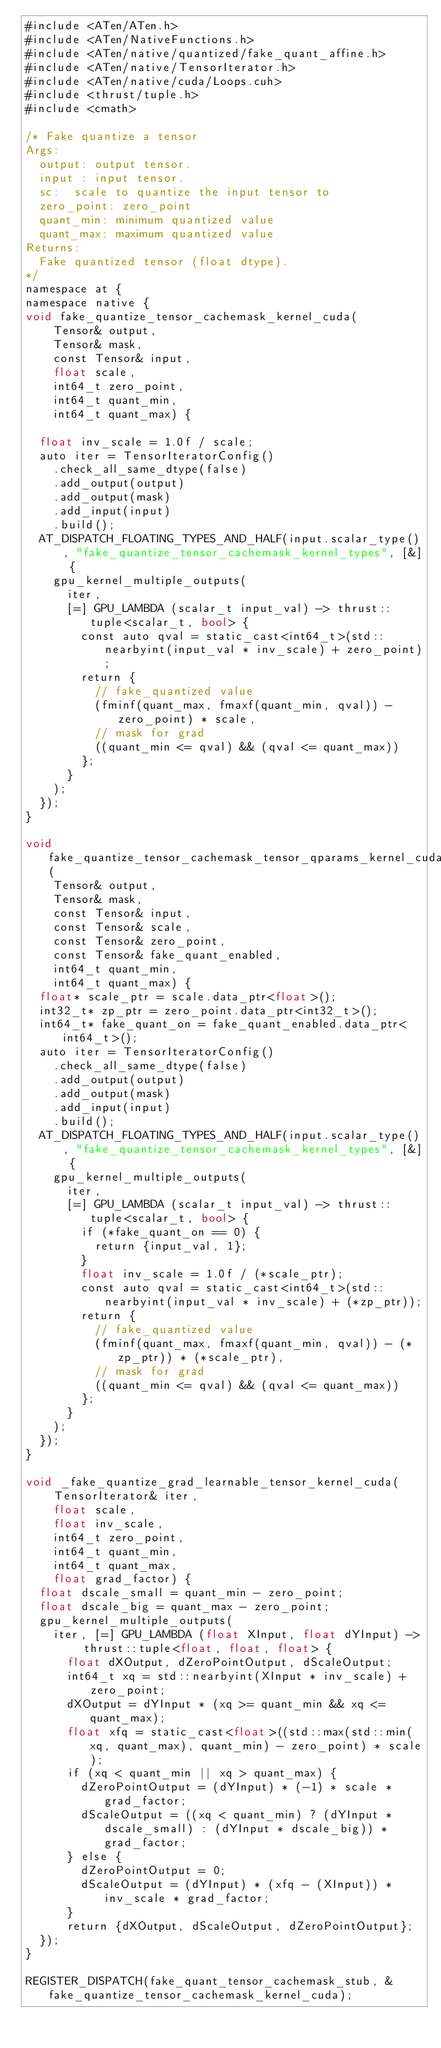<code> <loc_0><loc_0><loc_500><loc_500><_Cuda_>#include <ATen/ATen.h>
#include <ATen/NativeFunctions.h>
#include <ATen/native/quantized/fake_quant_affine.h>
#include <ATen/native/TensorIterator.h>
#include <ATen/native/cuda/Loops.cuh>
#include <thrust/tuple.h>
#include <cmath>

/* Fake quantize a tensor
Args:
  output: output tensor.
  input : input tensor.
  sc:  scale to quantize the input tensor to
  zero_point: zero_point
  quant_min: minimum quantized value
  quant_max: maximum quantized value
Returns:
  Fake quantized tensor (float dtype).
*/
namespace at {
namespace native {
void fake_quantize_tensor_cachemask_kernel_cuda(
    Tensor& output,
    Tensor& mask,
    const Tensor& input,
    float scale,
    int64_t zero_point,
    int64_t quant_min,
    int64_t quant_max) {

  float inv_scale = 1.0f / scale;
  auto iter = TensorIteratorConfig()
    .check_all_same_dtype(false)
    .add_output(output)
    .add_output(mask)
    .add_input(input)
    .build();
  AT_DISPATCH_FLOATING_TYPES_AND_HALF(input.scalar_type(), "fake_quantize_tensor_cachemask_kernel_types", [&] {
    gpu_kernel_multiple_outputs(
      iter,
      [=] GPU_LAMBDA (scalar_t input_val) -> thrust::tuple<scalar_t, bool> {
        const auto qval = static_cast<int64_t>(std::nearbyint(input_val * inv_scale) + zero_point);
        return {
          // fake_quantized value
          (fminf(quant_max, fmaxf(quant_min, qval)) - zero_point) * scale,
          // mask for grad
          ((quant_min <= qval) && (qval <= quant_max))
        };
      }
    );
  });
}

void fake_quantize_tensor_cachemask_tensor_qparams_kernel_cuda(
    Tensor& output,
    Tensor& mask,
    const Tensor& input,
    const Tensor& scale,
    const Tensor& zero_point,
    const Tensor& fake_quant_enabled,
    int64_t quant_min,
    int64_t quant_max) {
  float* scale_ptr = scale.data_ptr<float>();
  int32_t* zp_ptr = zero_point.data_ptr<int32_t>();
  int64_t* fake_quant_on = fake_quant_enabled.data_ptr<int64_t>();
  auto iter = TensorIteratorConfig()
    .check_all_same_dtype(false)
    .add_output(output)
    .add_output(mask)
    .add_input(input)
    .build();
  AT_DISPATCH_FLOATING_TYPES_AND_HALF(input.scalar_type(), "fake_quantize_tensor_cachemask_kernel_types", [&] {
    gpu_kernel_multiple_outputs(
      iter,
      [=] GPU_LAMBDA (scalar_t input_val) -> thrust::tuple<scalar_t, bool> {
        if (*fake_quant_on == 0) {
          return {input_val, 1};
        }
        float inv_scale = 1.0f / (*scale_ptr);
        const auto qval = static_cast<int64_t>(std::nearbyint(input_val * inv_scale) + (*zp_ptr));
        return {
          // fake_quantized value
          (fminf(quant_max, fmaxf(quant_min, qval)) - (*zp_ptr)) * (*scale_ptr),
          // mask for grad
          ((quant_min <= qval) && (qval <= quant_max))
        };
      }
    );
  });
}

void _fake_quantize_grad_learnable_tensor_kernel_cuda(
    TensorIterator& iter,
    float scale,
    float inv_scale,
    int64_t zero_point,
    int64_t quant_min,
    int64_t quant_max,
    float grad_factor) {
  float dscale_small = quant_min - zero_point;
  float dscale_big = quant_max - zero_point;
  gpu_kernel_multiple_outputs(
    iter, [=] GPU_LAMBDA (float XInput, float dYInput) -> thrust::tuple<float, float, float> {
      float dXOutput, dZeroPointOutput, dScaleOutput;
      int64_t xq = std::nearbyint(XInput * inv_scale) + zero_point;
      dXOutput = dYInput * (xq >= quant_min && xq <= quant_max);
      float xfq = static_cast<float>((std::max(std::min(xq, quant_max), quant_min) - zero_point) * scale);
      if (xq < quant_min || xq > quant_max) {
        dZeroPointOutput = (dYInput) * (-1) * scale * grad_factor;
        dScaleOutput = ((xq < quant_min) ? (dYInput * dscale_small) : (dYInput * dscale_big)) * grad_factor;
      } else {
        dZeroPointOutput = 0;
        dScaleOutput = (dYInput) * (xfq - (XInput)) * inv_scale * grad_factor;
      }
      return {dXOutput, dScaleOutput, dZeroPointOutput};
  });
}

REGISTER_DISPATCH(fake_quant_tensor_cachemask_stub, &fake_quantize_tensor_cachemask_kernel_cuda);</code> 